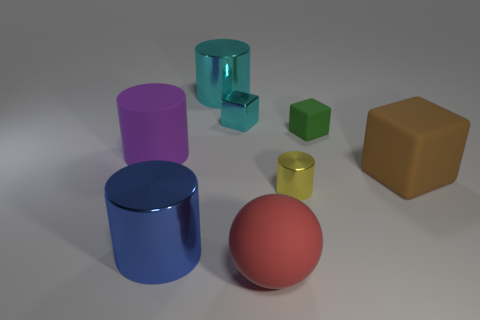Subtract 1 cylinders. How many cylinders are left? 3 Add 1 small metallic cubes. How many objects exist? 9 Subtract all blocks. How many objects are left? 5 Subtract all large brown cubes. Subtract all small green cubes. How many objects are left? 6 Add 5 small yellow metallic things. How many small yellow metallic things are left? 6 Add 5 large balls. How many large balls exist? 6 Subtract 0 gray cylinders. How many objects are left? 8 